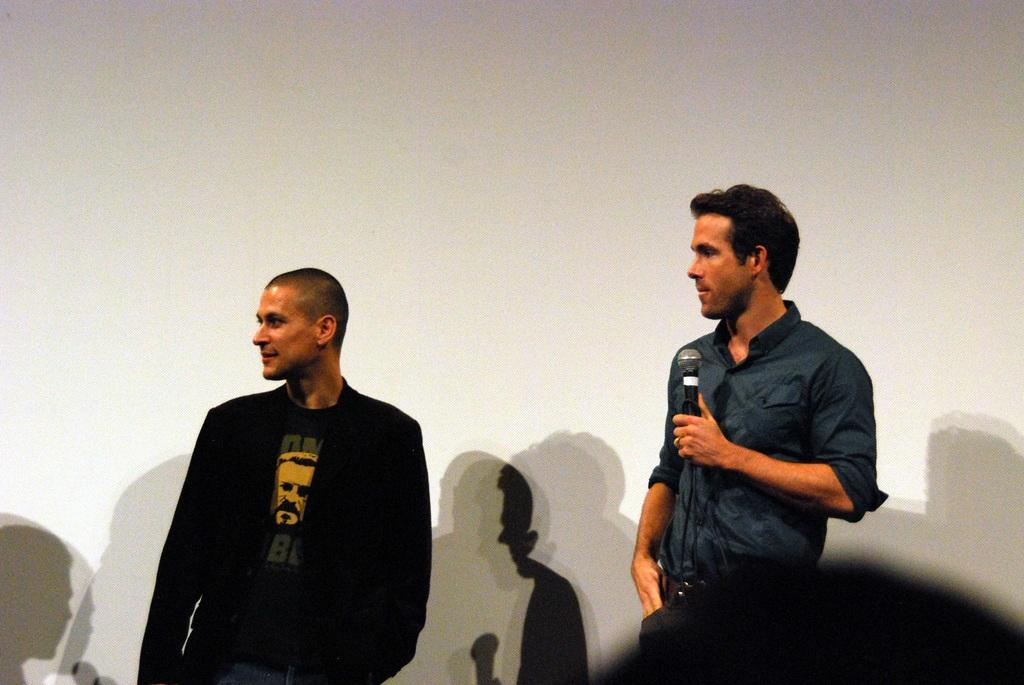How many people are present in the image? There are two men standing in the image. What is one of the men holding in the image? There is a man holding a microphone in the image. What can be seen behind the men in the image? There is a wall visible in the background of the image. What type of shoe is being used for digestion in the image? There is no shoe or digestion present in the image. How much dirt is visible on the wall in the image? There is no dirt visible on the wall in the image. 